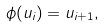Convert formula to latex. <formula><loc_0><loc_0><loc_500><loc_500>\phi ( u _ { i } ) = u _ { i + 1 } ,</formula> 